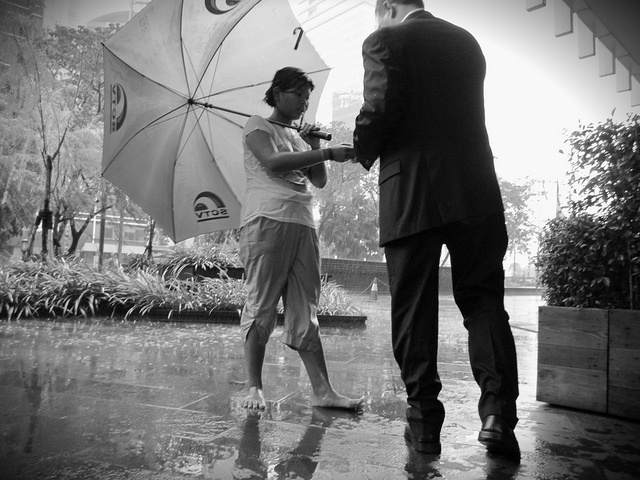Describe the objects in this image and their specific colors. I can see people in black, gray, darkgray, and lightgray tones, umbrella in black, darkgray, lightgray, and gray tones, potted plant in black, gray, white, and darkgray tones, and people in black, gray, darkgray, and lightgray tones in this image. 